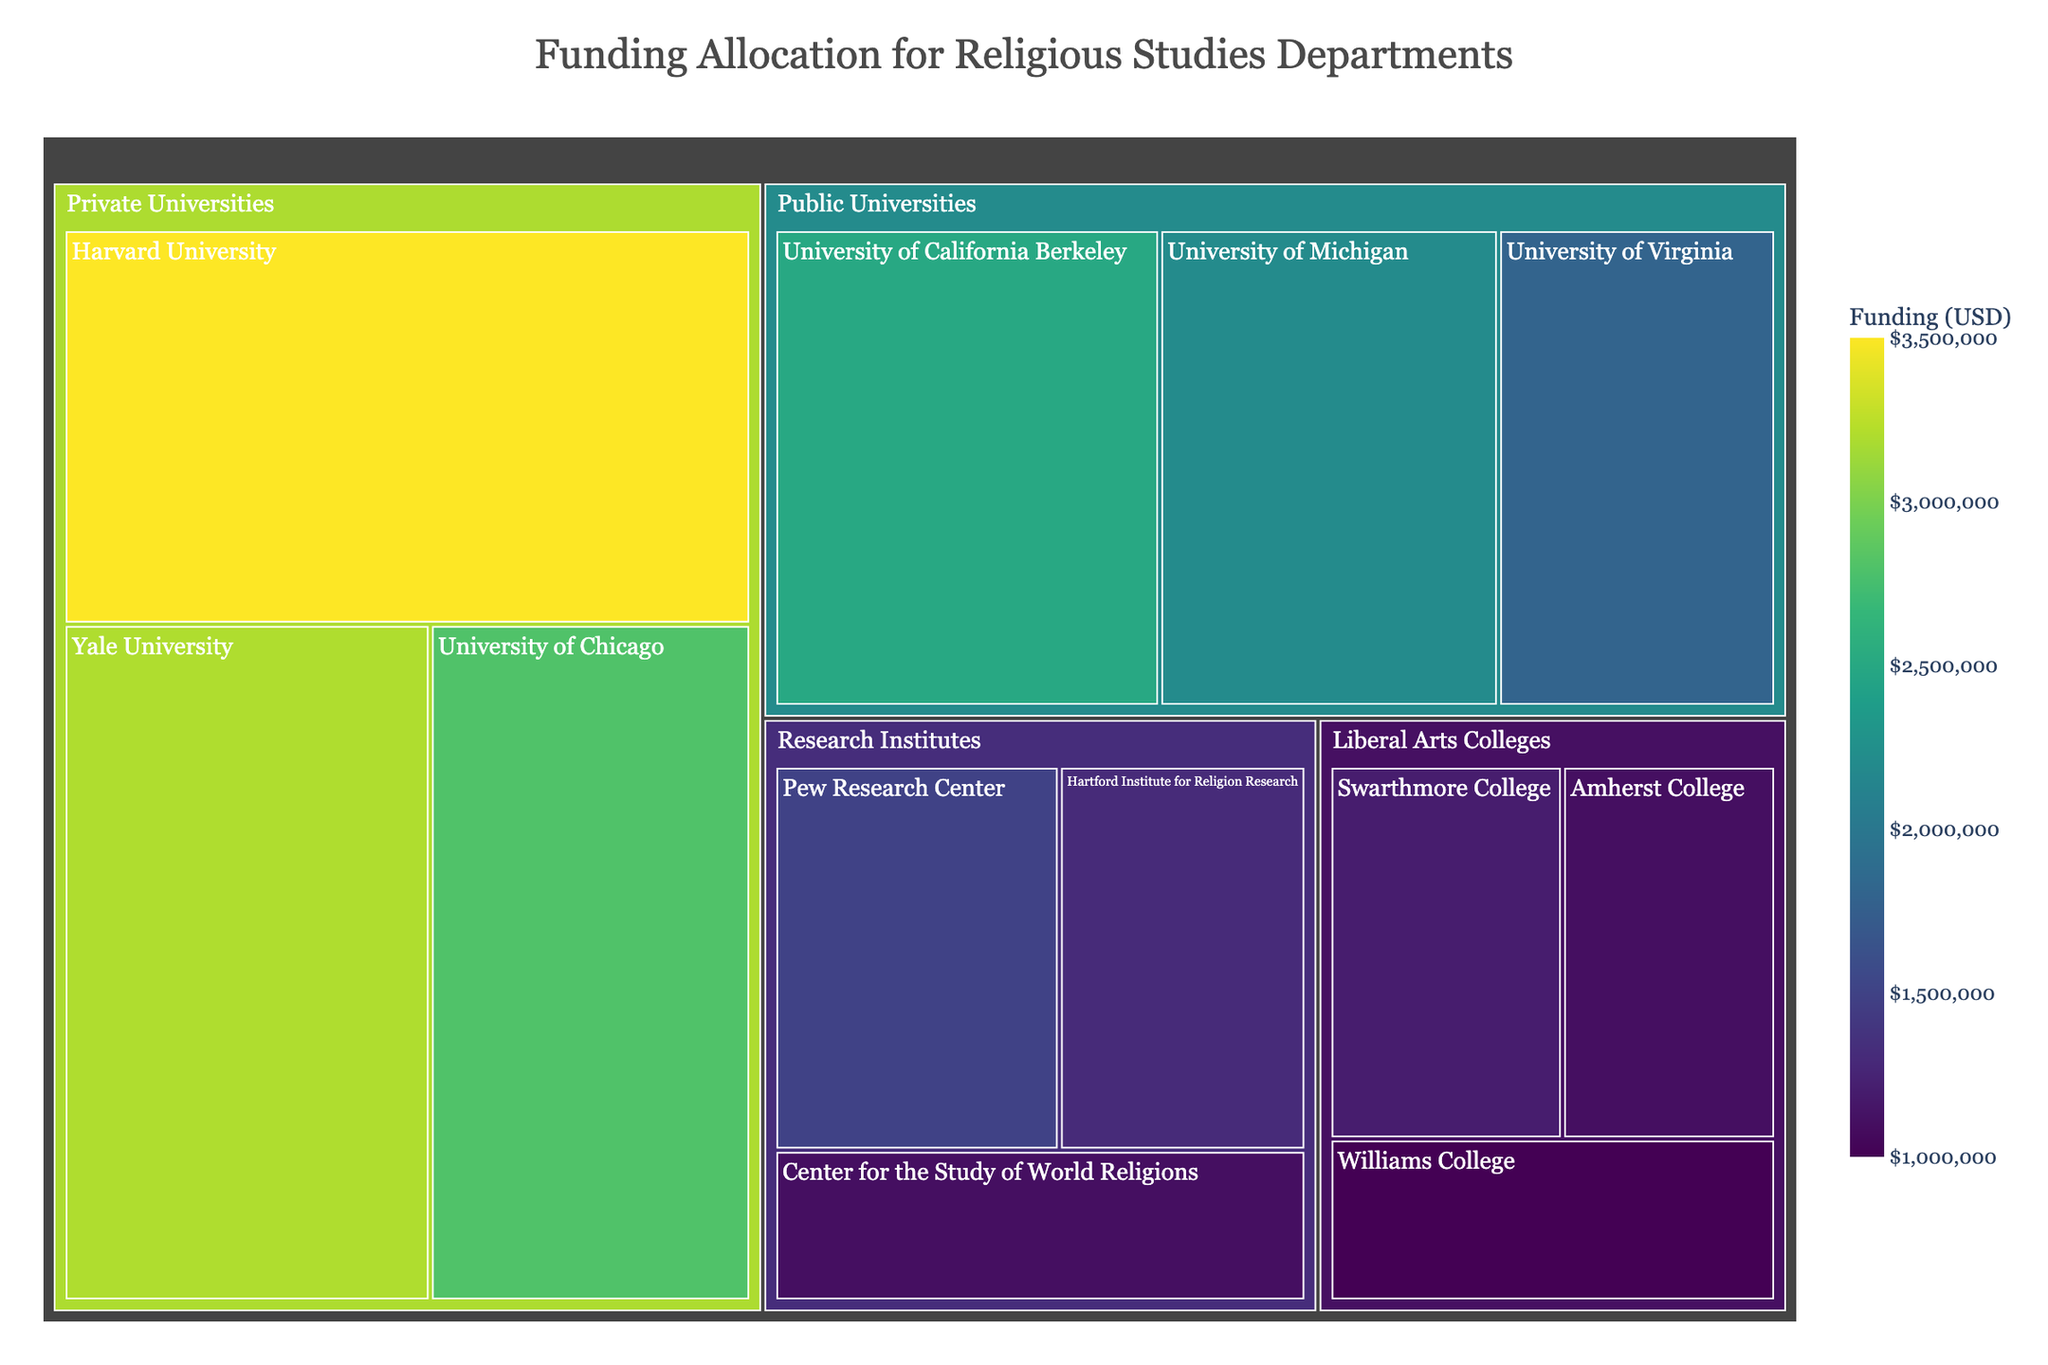what is the total funding allocated to Research Institutes? To find the total funding for Research Institutes, sum the allocations for Pew Research Center, Hartford Institute for Religion Research, and Center for the Study of World Religions: $1,500,000 + $1,300,000 + $1,100,000 = $3,900,000
Answer: $3,900,000 Which college received the highest funding among the Liberal Arts Colleges? The subcategories under Liberal Arts Colleges are Swarthmore College ($1,200,000), Amherst College ($1,100,000), and Williams College ($1,000,000). The highest among these is Swarthmore College.
Answer: Swarthmore College How does the funding for Yale University compare to that for University of Chicago? Yale University has a funding of $3,200,000, while University of Chicago has $2,800,000. Comparing these, Yale University has a higher allocation.
Answer: Yale University has more funding What is the average funding allocated to Public Universities? There are three Public Universities: University of California Berkeley ($2,500,000), University of Michigan ($2,200,000), and University of Virginia ($1,800,000). Their total funding is $2,500,000 + $2,200,000 + $1,800,000 = $6,500,000. The average is $6,500,000 / 3 = $2,166,666.67
Answer: $2,166,666.67 What is the funding difference between the highest and lowest funded subcategories? The highest funding is for Harvard University ($3,500,000) and the lowest is for Williams College ($1,000,000). The difference is $3,500,000 - $1,000,000 = $2,500,000.
Answer: $2,500,000 Which university among the Private Universities received less funding than University of Chicago? Private Universities listed are Harvard University ($3,500,000), Yale University ($3,200,000), and University of Chicago ($2,800,000). None of the listed universities received less funding than University of Chicago.
Answer: None How many universities fall under the category of Public Universities? The subcategories listed under Public Universities are: University of California Berkeley, University of Michigan, and University of Virginia. There are 3 universities.
Answer: 3 